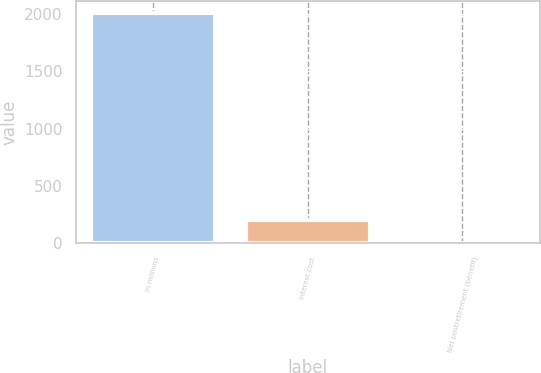Convert chart to OTSL. <chart><loc_0><loc_0><loc_500><loc_500><bar_chart><fcel>In millions<fcel>Interest cost<fcel>Net postretirement (benefit)<nl><fcel>2013<fcel>202.2<fcel>1<nl></chart> 